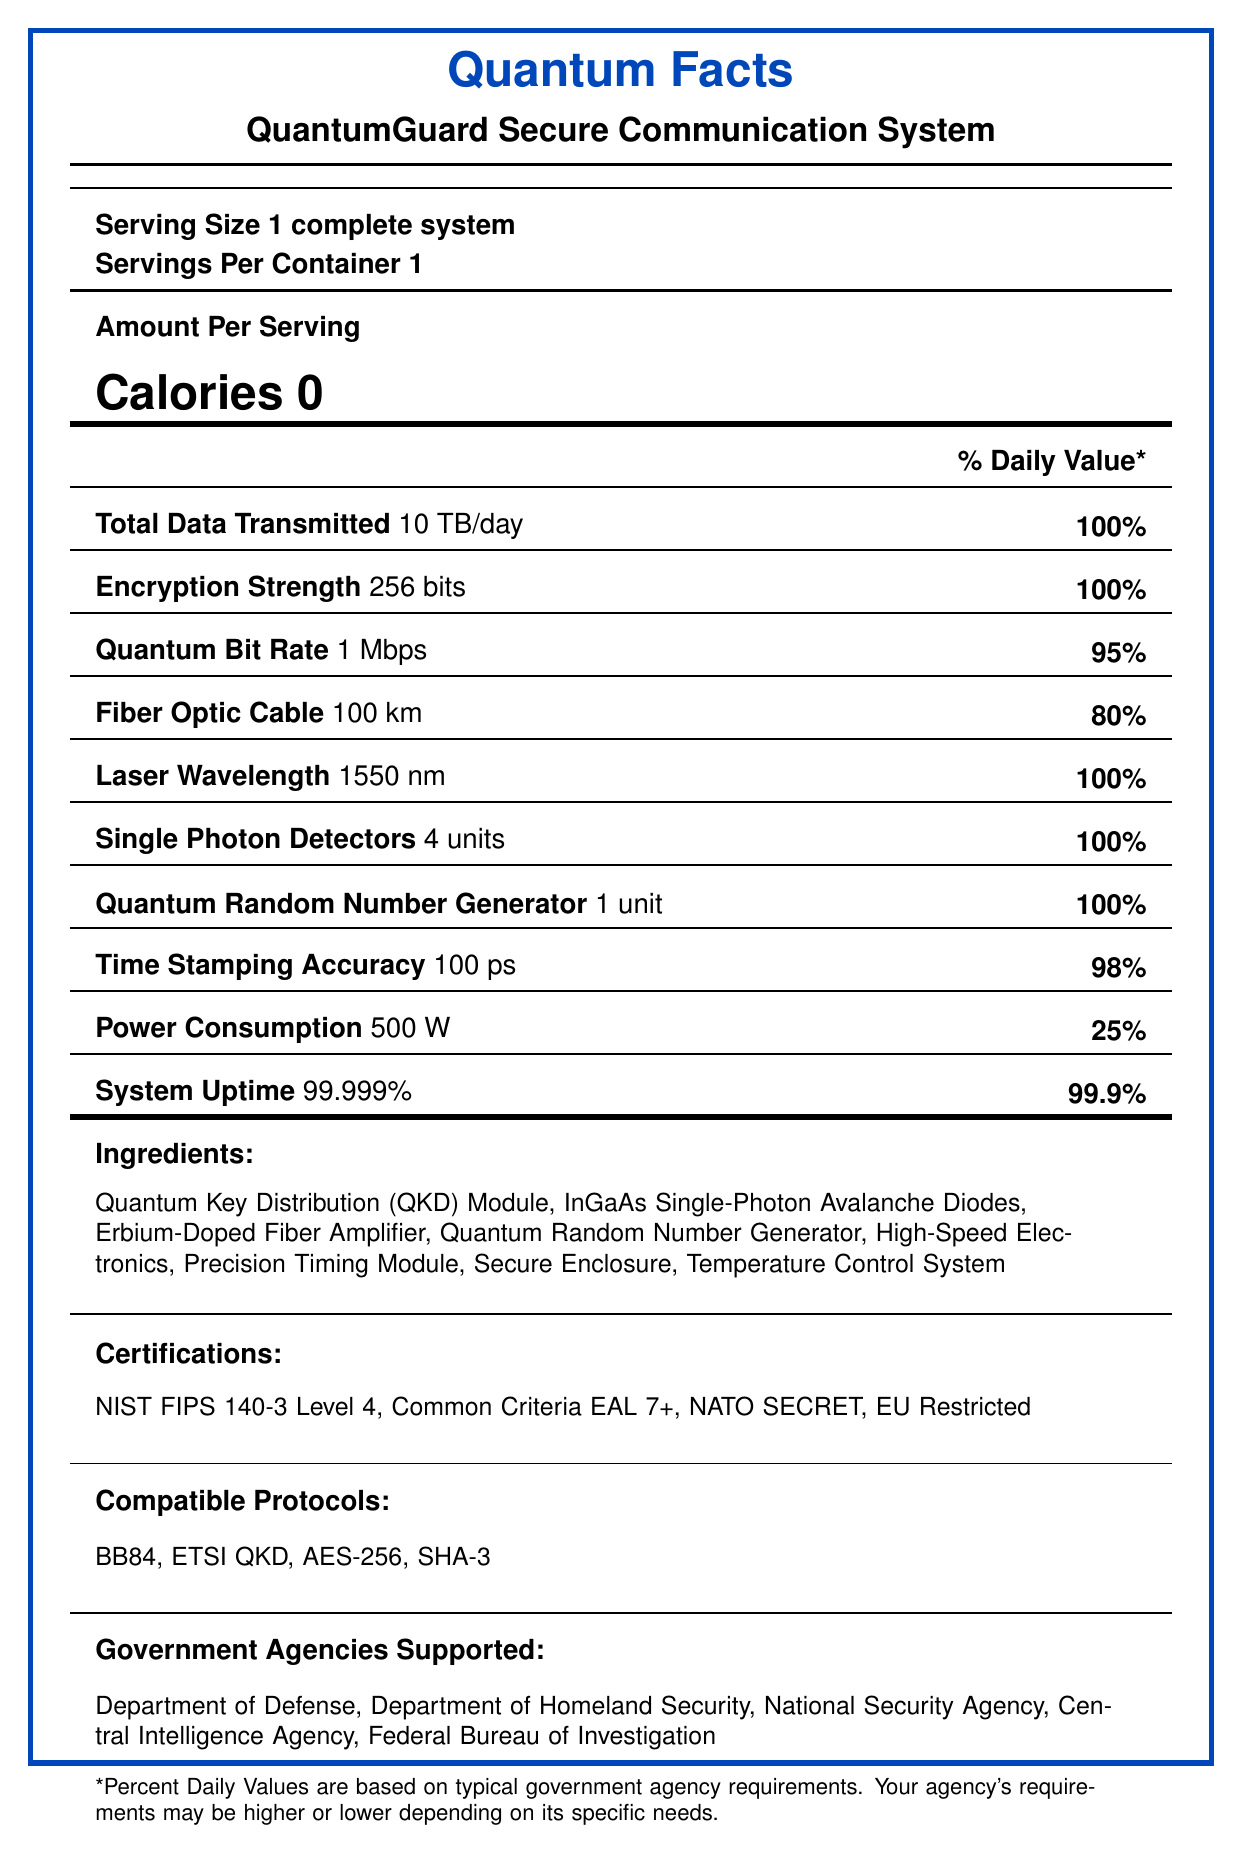What is the serving size for the QuantumGuard Secure Communication System? The document specifies the serving size as "1 complete system."
Answer: 1 complete system How much total data is transmitted per day? The document lists "Total Data Transmitted" as 10 TB/day.
Answer: 10 TB/day What is the encryption strength of the system? The document shows "Encryption Strength" as 256 bits.
Answer: 256 bits What wavelength of laser does the system use? The document states "Laser Wavelength" as 1550 nm.
Answer: 1550 nm How many single-photon detectors are included in the system? The document mentions "Single Photon Detectors" as 4 units.
Answer: 4 units What percentage daily value does the power consumption achieve? The document indicates the "Power Consumption" is 500 W with a daily value of 25%.
Answer: 25% Select the correct certification for the QuantumGuard System: A. ISO 27001 B. NIST FIPS 140-3 Level 4 C. SOC 2 The document lists "NIST FIPS 140-3 Level 4" as one of the certifications.
Answer: B Which of the following is NOT a compatible protocol? I. BB84 II. DES III. AES-256 The document lists BB84 and AES-256 among the compatible protocols but not DES.
Answer: II Does the system's serving size contain multiple units? The document specifies that the "Servings Per Container" is 1, meaning there is only one unit.
Answer: No Summarize the main idea of the document. The document provides detailed information about the QuantumGuard Secure Communication System, including its serving size, various technical specifications, performance metrics, ingredients, certifications, compatible protocols, and supported government agencies.
Answer: Overview of the QuantumGuard Secure Communication System and its specifications. What is the operational uptime percentage of the system? The document indicates "System Uptime" as 99.999%.
Answer: 99.999% List three government agencies that the QuantumGuard Secure Communication System supports. The document mentions that the Department of Defense, National Security Agency, and Department of Homeland Security are among the supported government agencies.
Answer: Department of Defense, National Security Agency, Department of Homeland Security How many units of the Quantum Random Number Generator are included? The document states "Quantum Random Number Generator" as 1 unit.
Answer: 1 unit What is the accuracy of the time-stamping feature in picoseconds? The document lists "Time Stamping Accuracy" as 100 ps.
Answer: 100 ps Can you determine the manufacturing cost of the system from the document? The document does not provide any data regarding the manufacturing cost of the system.
Answer: Not enough information What are two key components listed as ingredients of the QuantumGuard Secure Communication System? The document lists these components as part of the "Ingredients" section.
Answer: Quantum Key Distribution (QKD) Module, InGaAs Single-Photon Avalanche Diodes 